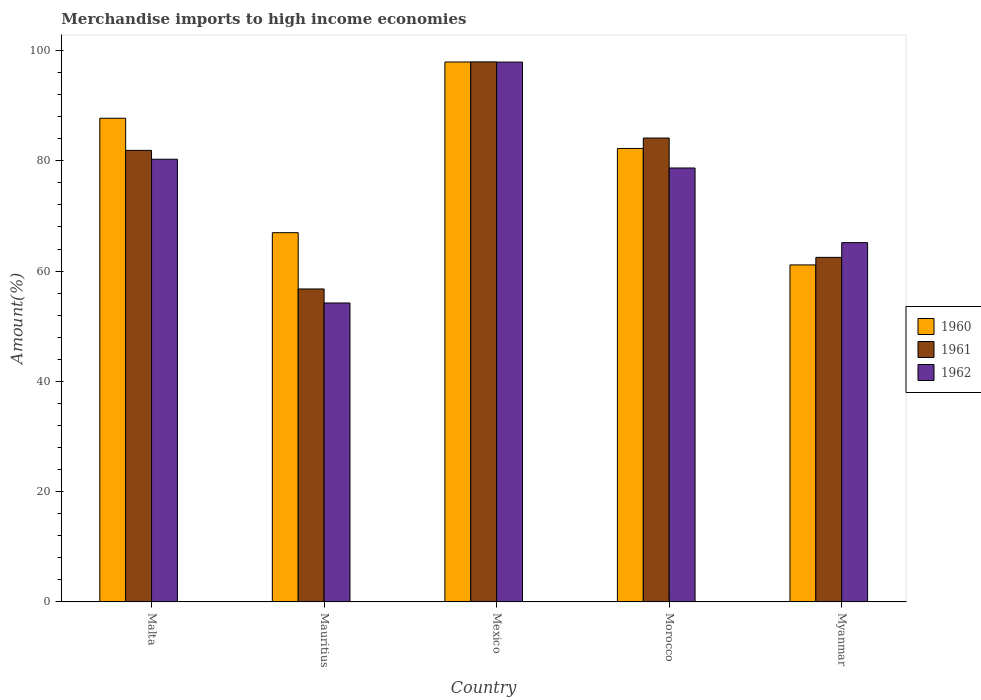How many groups of bars are there?
Provide a succinct answer. 5. Are the number of bars per tick equal to the number of legend labels?
Your answer should be very brief. Yes. Are the number of bars on each tick of the X-axis equal?
Your response must be concise. Yes. What is the label of the 5th group of bars from the left?
Give a very brief answer. Myanmar. In how many cases, is the number of bars for a given country not equal to the number of legend labels?
Offer a terse response. 0. What is the percentage of amount earned from merchandise imports in 1961 in Morocco?
Provide a succinct answer. 84.12. Across all countries, what is the maximum percentage of amount earned from merchandise imports in 1960?
Your answer should be compact. 97.91. Across all countries, what is the minimum percentage of amount earned from merchandise imports in 1962?
Make the answer very short. 54.21. In which country was the percentage of amount earned from merchandise imports in 1962 maximum?
Your answer should be compact. Mexico. In which country was the percentage of amount earned from merchandise imports in 1961 minimum?
Your answer should be compact. Mauritius. What is the total percentage of amount earned from merchandise imports in 1961 in the graph?
Your answer should be very brief. 383.18. What is the difference between the percentage of amount earned from merchandise imports in 1961 in Malta and that in Morocco?
Provide a succinct answer. -2.24. What is the difference between the percentage of amount earned from merchandise imports in 1960 in Myanmar and the percentage of amount earned from merchandise imports in 1962 in Morocco?
Your answer should be compact. -17.58. What is the average percentage of amount earned from merchandise imports in 1960 per country?
Offer a terse response. 79.19. What is the difference between the percentage of amount earned from merchandise imports of/in 1962 and percentage of amount earned from merchandise imports of/in 1960 in Myanmar?
Offer a very short reply. 4.04. In how many countries, is the percentage of amount earned from merchandise imports in 1962 greater than 80 %?
Provide a short and direct response. 2. What is the ratio of the percentage of amount earned from merchandise imports in 1960 in Mexico to that in Myanmar?
Your answer should be compact. 1.6. Is the percentage of amount earned from merchandise imports in 1960 in Morocco less than that in Myanmar?
Make the answer very short. No. Is the difference between the percentage of amount earned from merchandise imports in 1962 in Morocco and Myanmar greater than the difference between the percentage of amount earned from merchandise imports in 1960 in Morocco and Myanmar?
Offer a very short reply. No. What is the difference between the highest and the second highest percentage of amount earned from merchandise imports in 1962?
Keep it short and to the point. -17.62. What is the difference between the highest and the lowest percentage of amount earned from merchandise imports in 1960?
Ensure brevity in your answer.  36.8. Is it the case that in every country, the sum of the percentage of amount earned from merchandise imports in 1960 and percentage of amount earned from merchandise imports in 1962 is greater than the percentage of amount earned from merchandise imports in 1961?
Ensure brevity in your answer.  Yes. How many bars are there?
Your response must be concise. 15. Are all the bars in the graph horizontal?
Make the answer very short. No. What is the difference between two consecutive major ticks on the Y-axis?
Offer a very short reply. 20. Does the graph contain any zero values?
Your answer should be very brief. No. Where does the legend appear in the graph?
Provide a succinct answer. Center right. How many legend labels are there?
Offer a terse response. 3. What is the title of the graph?
Offer a very short reply. Merchandise imports to high income economies. What is the label or title of the Y-axis?
Make the answer very short. Amount(%). What is the Amount(%) of 1960 in Malta?
Provide a succinct answer. 87.71. What is the Amount(%) in 1961 in Malta?
Your answer should be compact. 81.89. What is the Amount(%) of 1962 in Malta?
Provide a succinct answer. 80.28. What is the Amount(%) of 1960 in Mauritius?
Your response must be concise. 66.96. What is the Amount(%) of 1961 in Mauritius?
Your answer should be compact. 56.75. What is the Amount(%) of 1962 in Mauritius?
Your answer should be compact. 54.21. What is the Amount(%) in 1960 in Mexico?
Your answer should be compact. 97.91. What is the Amount(%) in 1961 in Mexico?
Keep it short and to the point. 97.93. What is the Amount(%) of 1962 in Mexico?
Offer a terse response. 97.89. What is the Amount(%) of 1960 in Morocco?
Your answer should be very brief. 82.24. What is the Amount(%) of 1961 in Morocco?
Ensure brevity in your answer.  84.12. What is the Amount(%) in 1962 in Morocco?
Make the answer very short. 78.69. What is the Amount(%) of 1960 in Myanmar?
Your response must be concise. 61.11. What is the Amount(%) of 1961 in Myanmar?
Ensure brevity in your answer.  62.48. What is the Amount(%) in 1962 in Myanmar?
Provide a succinct answer. 65.15. Across all countries, what is the maximum Amount(%) of 1960?
Your response must be concise. 97.91. Across all countries, what is the maximum Amount(%) of 1961?
Give a very brief answer. 97.93. Across all countries, what is the maximum Amount(%) of 1962?
Provide a succinct answer. 97.89. Across all countries, what is the minimum Amount(%) of 1960?
Ensure brevity in your answer.  61.11. Across all countries, what is the minimum Amount(%) of 1961?
Offer a very short reply. 56.75. Across all countries, what is the minimum Amount(%) in 1962?
Offer a terse response. 54.21. What is the total Amount(%) of 1960 in the graph?
Offer a very short reply. 395.93. What is the total Amount(%) of 1961 in the graph?
Keep it short and to the point. 383.18. What is the total Amount(%) of 1962 in the graph?
Keep it short and to the point. 376.23. What is the difference between the Amount(%) of 1960 in Malta and that in Mauritius?
Provide a succinct answer. 20.75. What is the difference between the Amount(%) in 1961 in Malta and that in Mauritius?
Provide a succinct answer. 25.13. What is the difference between the Amount(%) in 1962 in Malta and that in Mauritius?
Keep it short and to the point. 26.07. What is the difference between the Amount(%) of 1960 in Malta and that in Mexico?
Offer a very short reply. -10.2. What is the difference between the Amount(%) of 1961 in Malta and that in Mexico?
Keep it short and to the point. -16.05. What is the difference between the Amount(%) of 1962 in Malta and that in Mexico?
Offer a terse response. -17.61. What is the difference between the Amount(%) of 1960 in Malta and that in Morocco?
Give a very brief answer. 5.47. What is the difference between the Amount(%) of 1961 in Malta and that in Morocco?
Provide a short and direct response. -2.24. What is the difference between the Amount(%) of 1962 in Malta and that in Morocco?
Your answer should be very brief. 1.59. What is the difference between the Amount(%) in 1960 in Malta and that in Myanmar?
Make the answer very short. 26.6. What is the difference between the Amount(%) in 1961 in Malta and that in Myanmar?
Keep it short and to the point. 19.4. What is the difference between the Amount(%) in 1962 in Malta and that in Myanmar?
Provide a short and direct response. 15.12. What is the difference between the Amount(%) in 1960 in Mauritius and that in Mexico?
Offer a very short reply. -30.95. What is the difference between the Amount(%) of 1961 in Mauritius and that in Mexico?
Ensure brevity in your answer.  -41.18. What is the difference between the Amount(%) in 1962 in Mauritius and that in Mexico?
Your answer should be very brief. -43.68. What is the difference between the Amount(%) in 1960 in Mauritius and that in Morocco?
Provide a succinct answer. -15.28. What is the difference between the Amount(%) of 1961 in Mauritius and that in Morocco?
Your response must be concise. -27.37. What is the difference between the Amount(%) in 1962 in Mauritius and that in Morocco?
Your answer should be very brief. -24.48. What is the difference between the Amount(%) in 1960 in Mauritius and that in Myanmar?
Provide a succinct answer. 5.85. What is the difference between the Amount(%) in 1961 in Mauritius and that in Myanmar?
Your answer should be very brief. -5.73. What is the difference between the Amount(%) in 1962 in Mauritius and that in Myanmar?
Ensure brevity in your answer.  -10.94. What is the difference between the Amount(%) of 1960 in Mexico and that in Morocco?
Your response must be concise. 15.68. What is the difference between the Amount(%) in 1961 in Mexico and that in Morocco?
Your answer should be very brief. 13.81. What is the difference between the Amount(%) of 1962 in Mexico and that in Morocco?
Provide a succinct answer. 19.2. What is the difference between the Amount(%) in 1960 in Mexico and that in Myanmar?
Keep it short and to the point. 36.8. What is the difference between the Amount(%) of 1961 in Mexico and that in Myanmar?
Give a very brief answer. 35.45. What is the difference between the Amount(%) in 1962 in Mexico and that in Myanmar?
Provide a succinct answer. 32.74. What is the difference between the Amount(%) in 1960 in Morocco and that in Myanmar?
Keep it short and to the point. 21.12. What is the difference between the Amount(%) in 1961 in Morocco and that in Myanmar?
Make the answer very short. 21.64. What is the difference between the Amount(%) of 1962 in Morocco and that in Myanmar?
Your response must be concise. 13.54. What is the difference between the Amount(%) of 1960 in Malta and the Amount(%) of 1961 in Mauritius?
Ensure brevity in your answer.  30.95. What is the difference between the Amount(%) in 1960 in Malta and the Amount(%) in 1962 in Mauritius?
Keep it short and to the point. 33.5. What is the difference between the Amount(%) in 1961 in Malta and the Amount(%) in 1962 in Mauritius?
Ensure brevity in your answer.  27.68. What is the difference between the Amount(%) in 1960 in Malta and the Amount(%) in 1961 in Mexico?
Offer a terse response. -10.22. What is the difference between the Amount(%) in 1960 in Malta and the Amount(%) in 1962 in Mexico?
Offer a terse response. -10.19. What is the difference between the Amount(%) in 1961 in Malta and the Amount(%) in 1962 in Mexico?
Give a very brief answer. -16.01. What is the difference between the Amount(%) of 1960 in Malta and the Amount(%) of 1961 in Morocco?
Give a very brief answer. 3.58. What is the difference between the Amount(%) of 1960 in Malta and the Amount(%) of 1962 in Morocco?
Offer a terse response. 9.02. What is the difference between the Amount(%) of 1961 in Malta and the Amount(%) of 1962 in Morocco?
Offer a very short reply. 3.2. What is the difference between the Amount(%) in 1960 in Malta and the Amount(%) in 1961 in Myanmar?
Make the answer very short. 25.23. What is the difference between the Amount(%) of 1960 in Malta and the Amount(%) of 1962 in Myanmar?
Offer a terse response. 22.55. What is the difference between the Amount(%) in 1961 in Malta and the Amount(%) in 1962 in Myanmar?
Make the answer very short. 16.73. What is the difference between the Amount(%) in 1960 in Mauritius and the Amount(%) in 1961 in Mexico?
Provide a short and direct response. -30.97. What is the difference between the Amount(%) in 1960 in Mauritius and the Amount(%) in 1962 in Mexico?
Your answer should be compact. -30.93. What is the difference between the Amount(%) of 1961 in Mauritius and the Amount(%) of 1962 in Mexico?
Your response must be concise. -41.14. What is the difference between the Amount(%) in 1960 in Mauritius and the Amount(%) in 1961 in Morocco?
Keep it short and to the point. -17.16. What is the difference between the Amount(%) of 1960 in Mauritius and the Amount(%) of 1962 in Morocco?
Make the answer very short. -11.73. What is the difference between the Amount(%) in 1961 in Mauritius and the Amount(%) in 1962 in Morocco?
Your response must be concise. -21.94. What is the difference between the Amount(%) of 1960 in Mauritius and the Amount(%) of 1961 in Myanmar?
Ensure brevity in your answer.  4.48. What is the difference between the Amount(%) in 1960 in Mauritius and the Amount(%) in 1962 in Myanmar?
Give a very brief answer. 1.81. What is the difference between the Amount(%) in 1961 in Mauritius and the Amount(%) in 1962 in Myanmar?
Offer a terse response. -8.4. What is the difference between the Amount(%) of 1960 in Mexico and the Amount(%) of 1961 in Morocco?
Keep it short and to the point. 13.79. What is the difference between the Amount(%) of 1960 in Mexico and the Amount(%) of 1962 in Morocco?
Provide a short and direct response. 19.22. What is the difference between the Amount(%) of 1961 in Mexico and the Amount(%) of 1962 in Morocco?
Give a very brief answer. 19.24. What is the difference between the Amount(%) of 1960 in Mexico and the Amount(%) of 1961 in Myanmar?
Offer a terse response. 35.43. What is the difference between the Amount(%) in 1960 in Mexico and the Amount(%) in 1962 in Myanmar?
Give a very brief answer. 32.76. What is the difference between the Amount(%) in 1961 in Mexico and the Amount(%) in 1962 in Myanmar?
Ensure brevity in your answer.  32.78. What is the difference between the Amount(%) in 1960 in Morocco and the Amount(%) in 1961 in Myanmar?
Provide a succinct answer. 19.75. What is the difference between the Amount(%) of 1960 in Morocco and the Amount(%) of 1962 in Myanmar?
Make the answer very short. 17.08. What is the difference between the Amount(%) in 1961 in Morocco and the Amount(%) in 1962 in Myanmar?
Make the answer very short. 18.97. What is the average Amount(%) of 1960 per country?
Make the answer very short. 79.19. What is the average Amount(%) of 1961 per country?
Keep it short and to the point. 76.64. What is the average Amount(%) of 1962 per country?
Keep it short and to the point. 75.25. What is the difference between the Amount(%) in 1960 and Amount(%) in 1961 in Malta?
Give a very brief answer. 5.82. What is the difference between the Amount(%) of 1960 and Amount(%) of 1962 in Malta?
Your response must be concise. 7.43. What is the difference between the Amount(%) in 1961 and Amount(%) in 1962 in Malta?
Make the answer very short. 1.61. What is the difference between the Amount(%) in 1960 and Amount(%) in 1961 in Mauritius?
Give a very brief answer. 10.21. What is the difference between the Amount(%) in 1960 and Amount(%) in 1962 in Mauritius?
Provide a succinct answer. 12.75. What is the difference between the Amount(%) in 1961 and Amount(%) in 1962 in Mauritius?
Your answer should be compact. 2.54. What is the difference between the Amount(%) in 1960 and Amount(%) in 1961 in Mexico?
Offer a terse response. -0.02. What is the difference between the Amount(%) of 1960 and Amount(%) of 1962 in Mexico?
Your answer should be compact. 0.02. What is the difference between the Amount(%) in 1961 and Amount(%) in 1962 in Mexico?
Ensure brevity in your answer.  0.04. What is the difference between the Amount(%) of 1960 and Amount(%) of 1961 in Morocco?
Give a very brief answer. -1.89. What is the difference between the Amount(%) in 1960 and Amount(%) in 1962 in Morocco?
Make the answer very short. 3.54. What is the difference between the Amount(%) of 1961 and Amount(%) of 1962 in Morocco?
Your response must be concise. 5.43. What is the difference between the Amount(%) in 1960 and Amount(%) in 1961 in Myanmar?
Your response must be concise. -1.37. What is the difference between the Amount(%) in 1960 and Amount(%) in 1962 in Myanmar?
Ensure brevity in your answer.  -4.04. What is the difference between the Amount(%) of 1961 and Amount(%) of 1962 in Myanmar?
Your answer should be compact. -2.67. What is the ratio of the Amount(%) in 1960 in Malta to that in Mauritius?
Make the answer very short. 1.31. What is the ratio of the Amount(%) of 1961 in Malta to that in Mauritius?
Make the answer very short. 1.44. What is the ratio of the Amount(%) of 1962 in Malta to that in Mauritius?
Your answer should be compact. 1.48. What is the ratio of the Amount(%) in 1960 in Malta to that in Mexico?
Provide a short and direct response. 0.9. What is the ratio of the Amount(%) of 1961 in Malta to that in Mexico?
Offer a terse response. 0.84. What is the ratio of the Amount(%) of 1962 in Malta to that in Mexico?
Make the answer very short. 0.82. What is the ratio of the Amount(%) of 1960 in Malta to that in Morocco?
Provide a succinct answer. 1.07. What is the ratio of the Amount(%) of 1961 in Malta to that in Morocco?
Your response must be concise. 0.97. What is the ratio of the Amount(%) of 1962 in Malta to that in Morocco?
Make the answer very short. 1.02. What is the ratio of the Amount(%) in 1960 in Malta to that in Myanmar?
Your answer should be very brief. 1.44. What is the ratio of the Amount(%) of 1961 in Malta to that in Myanmar?
Make the answer very short. 1.31. What is the ratio of the Amount(%) of 1962 in Malta to that in Myanmar?
Your answer should be very brief. 1.23. What is the ratio of the Amount(%) in 1960 in Mauritius to that in Mexico?
Offer a very short reply. 0.68. What is the ratio of the Amount(%) of 1961 in Mauritius to that in Mexico?
Provide a short and direct response. 0.58. What is the ratio of the Amount(%) in 1962 in Mauritius to that in Mexico?
Offer a very short reply. 0.55. What is the ratio of the Amount(%) of 1960 in Mauritius to that in Morocco?
Make the answer very short. 0.81. What is the ratio of the Amount(%) in 1961 in Mauritius to that in Morocco?
Ensure brevity in your answer.  0.67. What is the ratio of the Amount(%) of 1962 in Mauritius to that in Morocco?
Offer a terse response. 0.69. What is the ratio of the Amount(%) in 1960 in Mauritius to that in Myanmar?
Provide a succinct answer. 1.1. What is the ratio of the Amount(%) of 1961 in Mauritius to that in Myanmar?
Provide a short and direct response. 0.91. What is the ratio of the Amount(%) of 1962 in Mauritius to that in Myanmar?
Your response must be concise. 0.83. What is the ratio of the Amount(%) of 1960 in Mexico to that in Morocco?
Offer a terse response. 1.19. What is the ratio of the Amount(%) of 1961 in Mexico to that in Morocco?
Provide a short and direct response. 1.16. What is the ratio of the Amount(%) in 1962 in Mexico to that in Morocco?
Give a very brief answer. 1.24. What is the ratio of the Amount(%) of 1960 in Mexico to that in Myanmar?
Give a very brief answer. 1.6. What is the ratio of the Amount(%) in 1961 in Mexico to that in Myanmar?
Your answer should be compact. 1.57. What is the ratio of the Amount(%) of 1962 in Mexico to that in Myanmar?
Your response must be concise. 1.5. What is the ratio of the Amount(%) of 1960 in Morocco to that in Myanmar?
Ensure brevity in your answer.  1.35. What is the ratio of the Amount(%) of 1961 in Morocco to that in Myanmar?
Your answer should be very brief. 1.35. What is the ratio of the Amount(%) of 1962 in Morocco to that in Myanmar?
Offer a very short reply. 1.21. What is the difference between the highest and the second highest Amount(%) in 1960?
Make the answer very short. 10.2. What is the difference between the highest and the second highest Amount(%) in 1961?
Provide a succinct answer. 13.81. What is the difference between the highest and the second highest Amount(%) of 1962?
Make the answer very short. 17.61. What is the difference between the highest and the lowest Amount(%) of 1960?
Give a very brief answer. 36.8. What is the difference between the highest and the lowest Amount(%) in 1961?
Keep it short and to the point. 41.18. What is the difference between the highest and the lowest Amount(%) of 1962?
Your answer should be very brief. 43.68. 